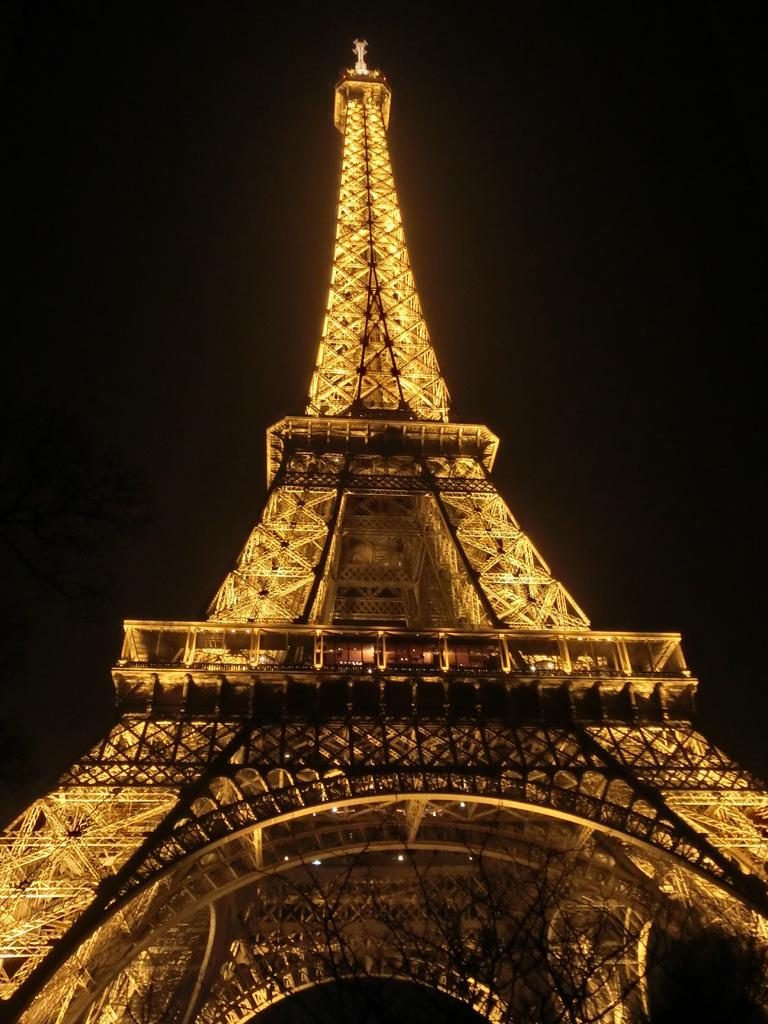What famous landmark can be seen in the image? The Eiffel Tower is visible in the image. Can you describe the background of the image? The background of the image appears to be dark. What type of feather can be seen falling from the Eiffel Tower in the image? There is no feather falling from the Eiffel Tower in the image. What kind of loaf is being served at the restaurant near the Eiffel Tower in the image? There is no restaurant or loaf present in the image; it only features the Eiffel Tower. 